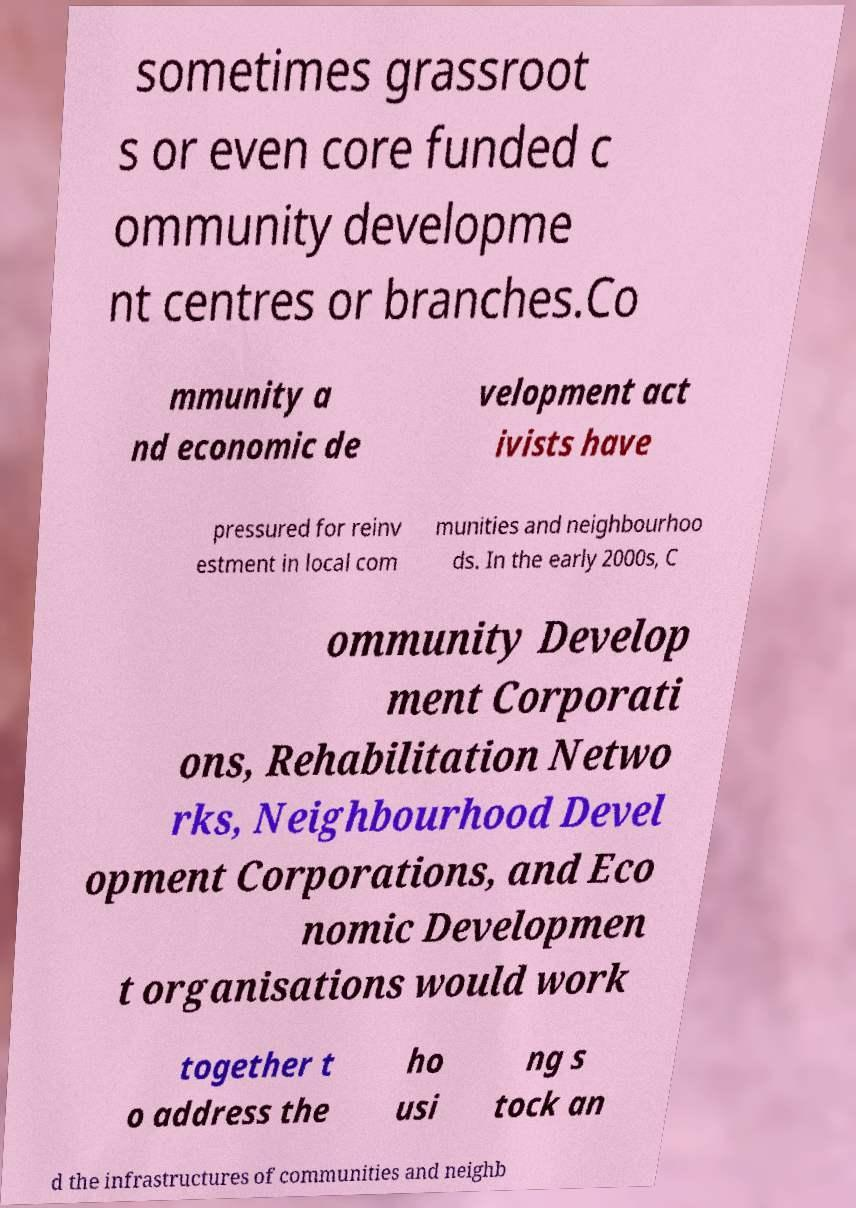Could you extract and type out the text from this image? sometimes grassroot s or even core funded c ommunity developme nt centres or branches.Co mmunity a nd economic de velopment act ivists have pressured for reinv estment in local com munities and neighbourhoo ds. In the early 2000s, C ommunity Develop ment Corporati ons, Rehabilitation Netwo rks, Neighbourhood Devel opment Corporations, and Eco nomic Developmen t organisations would work together t o address the ho usi ng s tock an d the infrastructures of communities and neighb 